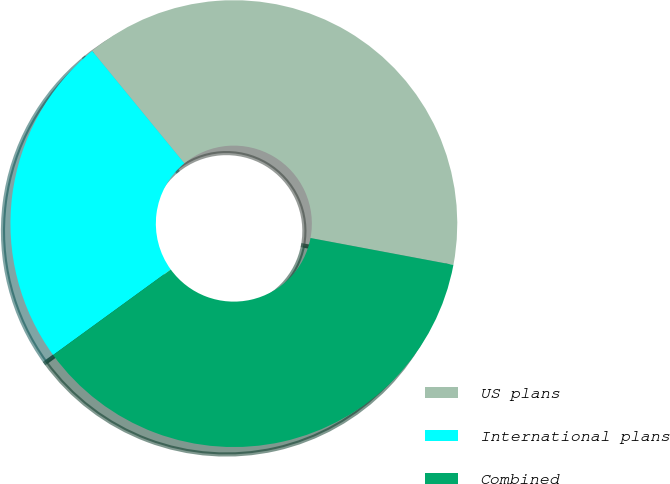Convert chart. <chart><loc_0><loc_0><loc_500><loc_500><pie_chart><fcel>US plans<fcel>International plans<fcel>Combined<nl><fcel>38.89%<fcel>24.07%<fcel>37.04%<nl></chart> 